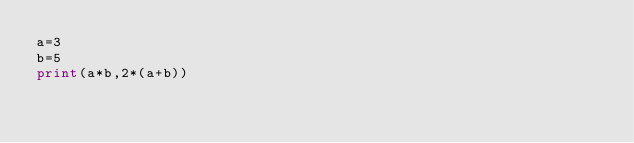Convert code to text. <code><loc_0><loc_0><loc_500><loc_500><_Python_>a=3
b=5
print(a*b,2*(a+b))

</code> 